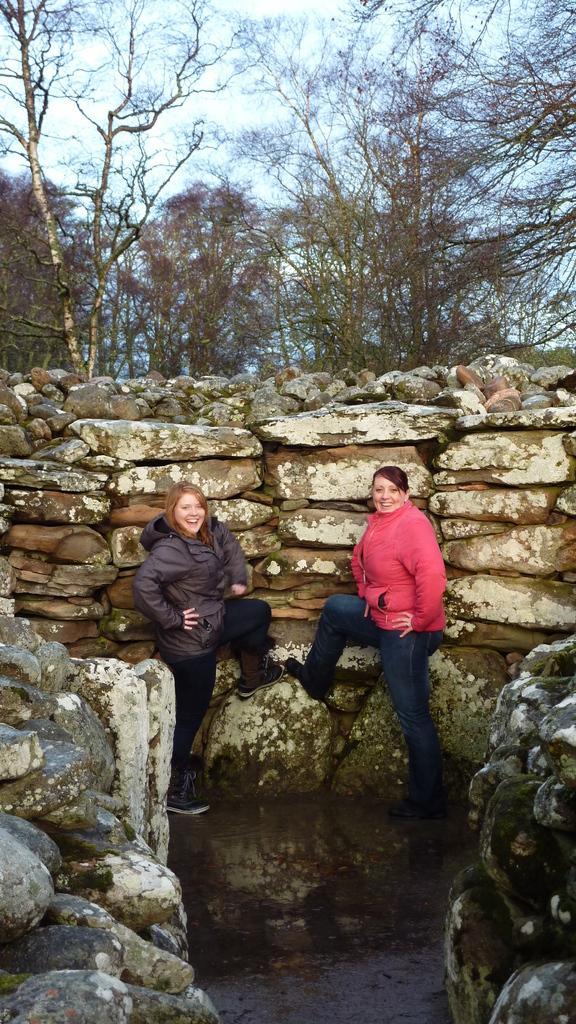In one or two sentences, can you explain what this image depicts? In this image I can see a rack in front of rack I can see two persons at the top there is the sky and trees visible. 